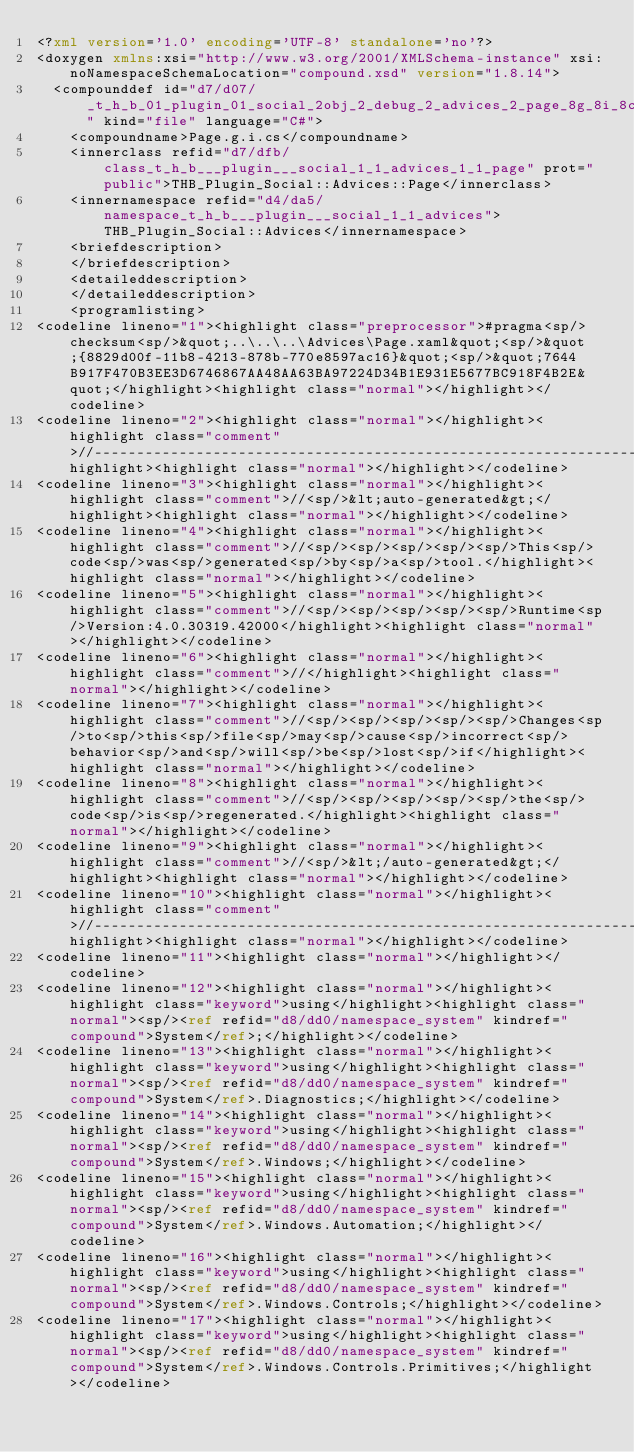Convert code to text. <code><loc_0><loc_0><loc_500><loc_500><_XML_><?xml version='1.0' encoding='UTF-8' standalone='no'?>
<doxygen xmlns:xsi="http://www.w3.org/2001/XMLSchema-instance" xsi:noNamespaceSchemaLocation="compound.xsd" version="1.8.14">
  <compounddef id="d7/d07/_t_h_b_01_plugin_01_social_2obj_2_debug_2_advices_2_page_8g_8i_8cs" kind="file" language="C#">
    <compoundname>Page.g.i.cs</compoundname>
    <innerclass refid="d7/dfb/class_t_h_b___plugin___social_1_1_advices_1_1_page" prot="public">THB_Plugin_Social::Advices::Page</innerclass>
    <innernamespace refid="d4/da5/namespace_t_h_b___plugin___social_1_1_advices">THB_Plugin_Social::Advices</innernamespace>
    <briefdescription>
    </briefdescription>
    <detaileddescription>
    </detaileddescription>
    <programlisting>
<codeline lineno="1"><highlight class="preprocessor">#pragma<sp/>checksum<sp/>&quot;..\..\..\Advices\Page.xaml&quot;<sp/>&quot;{8829d00f-11b8-4213-878b-770e8597ac16}&quot;<sp/>&quot;7644B917F470B3EE3D6746867AA48AA63BA97224D34B1E931E5677BC918F4B2E&quot;</highlight><highlight class="normal"></highlight></codeline>
<codeline lineno="2"><highlight class="normal"></highlight><highlight class="comment">//------------------------------------------------------------------------------</highlight><highlight class="normal"></highlight></codeline>
<codeline lineno="3"><highlight class="normal"></highlight><highlight class="comment">//<sp/>&lt;auto-generated&gt;</highlight><highlight class="normal"></highlight></codeline>
<codeline lineno="4"><highlight class="normal"></highlight><highlight class="comment">//<sp/><sp/><sp/><sp/><sp/>This<sp/>code<sp/>was<sp/>generated<sp/>by<sp/>a<sp/>tool.</highlight><highlight class="normal"></highlight></codeline>
<codeline lineno="5"><highlight class="normal"></highlight><highlight class="comment">//<sp/><sp/><sp/><sp/><sp/>Runtime<sp/>Version:4.0.30319.42000</highlight><highlight class="normal"></highlight></codeline>
<codeline lineno="6"><highlight class="normal"></highlight><highlight class="comment">//</highlight><highlight class="normal"></highlight></codeline>
<codeline lineno="7"><highlight class="normal"></highlight><highlight class="comment">//<sp/><sp/><sp/><sp/><sp/>Changes<sp/>to<sp/>this<sp/>file<sp/>may<sp/>cause<sp/>incorrect<sp/>behavior<sp/>and<sp/>will<sp/>be<sp/>lost<sp/>if</highlight><highlight class="normal"></highlight></codeline>
<codeline lineno="8"><highlight class="normal"></highlight><highlight class="comment">//<sp/><sp/><sp/><sp/><sp/>the<sp/>code<sp/>is<sp/>regenerated.</highlight><highlight class="normal"></highlight></codeline>
<codeline lineno="9"><highlight class="normal"></highlight><highlight class="comment">//<sp/>&lt;/auto-generated&gt;</highlight><highlight class="normal"></highlight></codeline>
<codeline lineno="10"><highlight class="normal"></highlight><highlight class="comment">//------------------------------------------------------------------------------</highlight><highlight class="normal"></highlight></codeline>
<codeline lineno="11"><highlight class="normal"></highlight></codeline>
<codeline lineno="12"><highlight class="normal"></highlight><highlight class="keyword">using</highlight><highlight class="normal"><sp/><ref refid="d8/dd0/namespace_system" kindref="compound">System</ref>;</highlight></codeline>
<codeline lineno="13"><highlight class="normal"></highlight><highlight class="keyword">using</highlight><highlight class="normal"><sp/><ref refid="d8/dd0/namespace_system" kindref="compound">System</ref>.Diagnostics;</highlight></codeline>
<codeline lineno="14"><highlight class="normal"></highlight><highlight class="keyword">using</highlight><highlight class="normal"><sp/><ref refid="d8/dd0/namespace_system" kindref="compound">System</ref>.Windows;</highlight></codeline>
<codeline lineno="15"><highlight class="normal"></highlight><highlight class="keyword">using</highlight><highlight class="normal"><sp/><ref refid="d8/dd0/namespace_system" kindref="compound">System</ref>.Windows.Automation;</highlight></codeline>
<codeline lineno="16"><highlight class="normal"></highlight><highlight class="keyword">using</highlight><highlight class="normal"><sp/><ref refid="d8/dd0/namespace_system" kindref="compound">System</ref>.Windows.Controls;</highlight></codeline>
<codeline lineno="17"><highlight class="normal"></highlight><highlight class="keyword">using</highlight><highlight class="normal"><sp/><ref refid="d8/dd0/namespace_system" kindref="compound">System</ref>.Windows.Controls.Primitives;</highlight></codeline></code> 